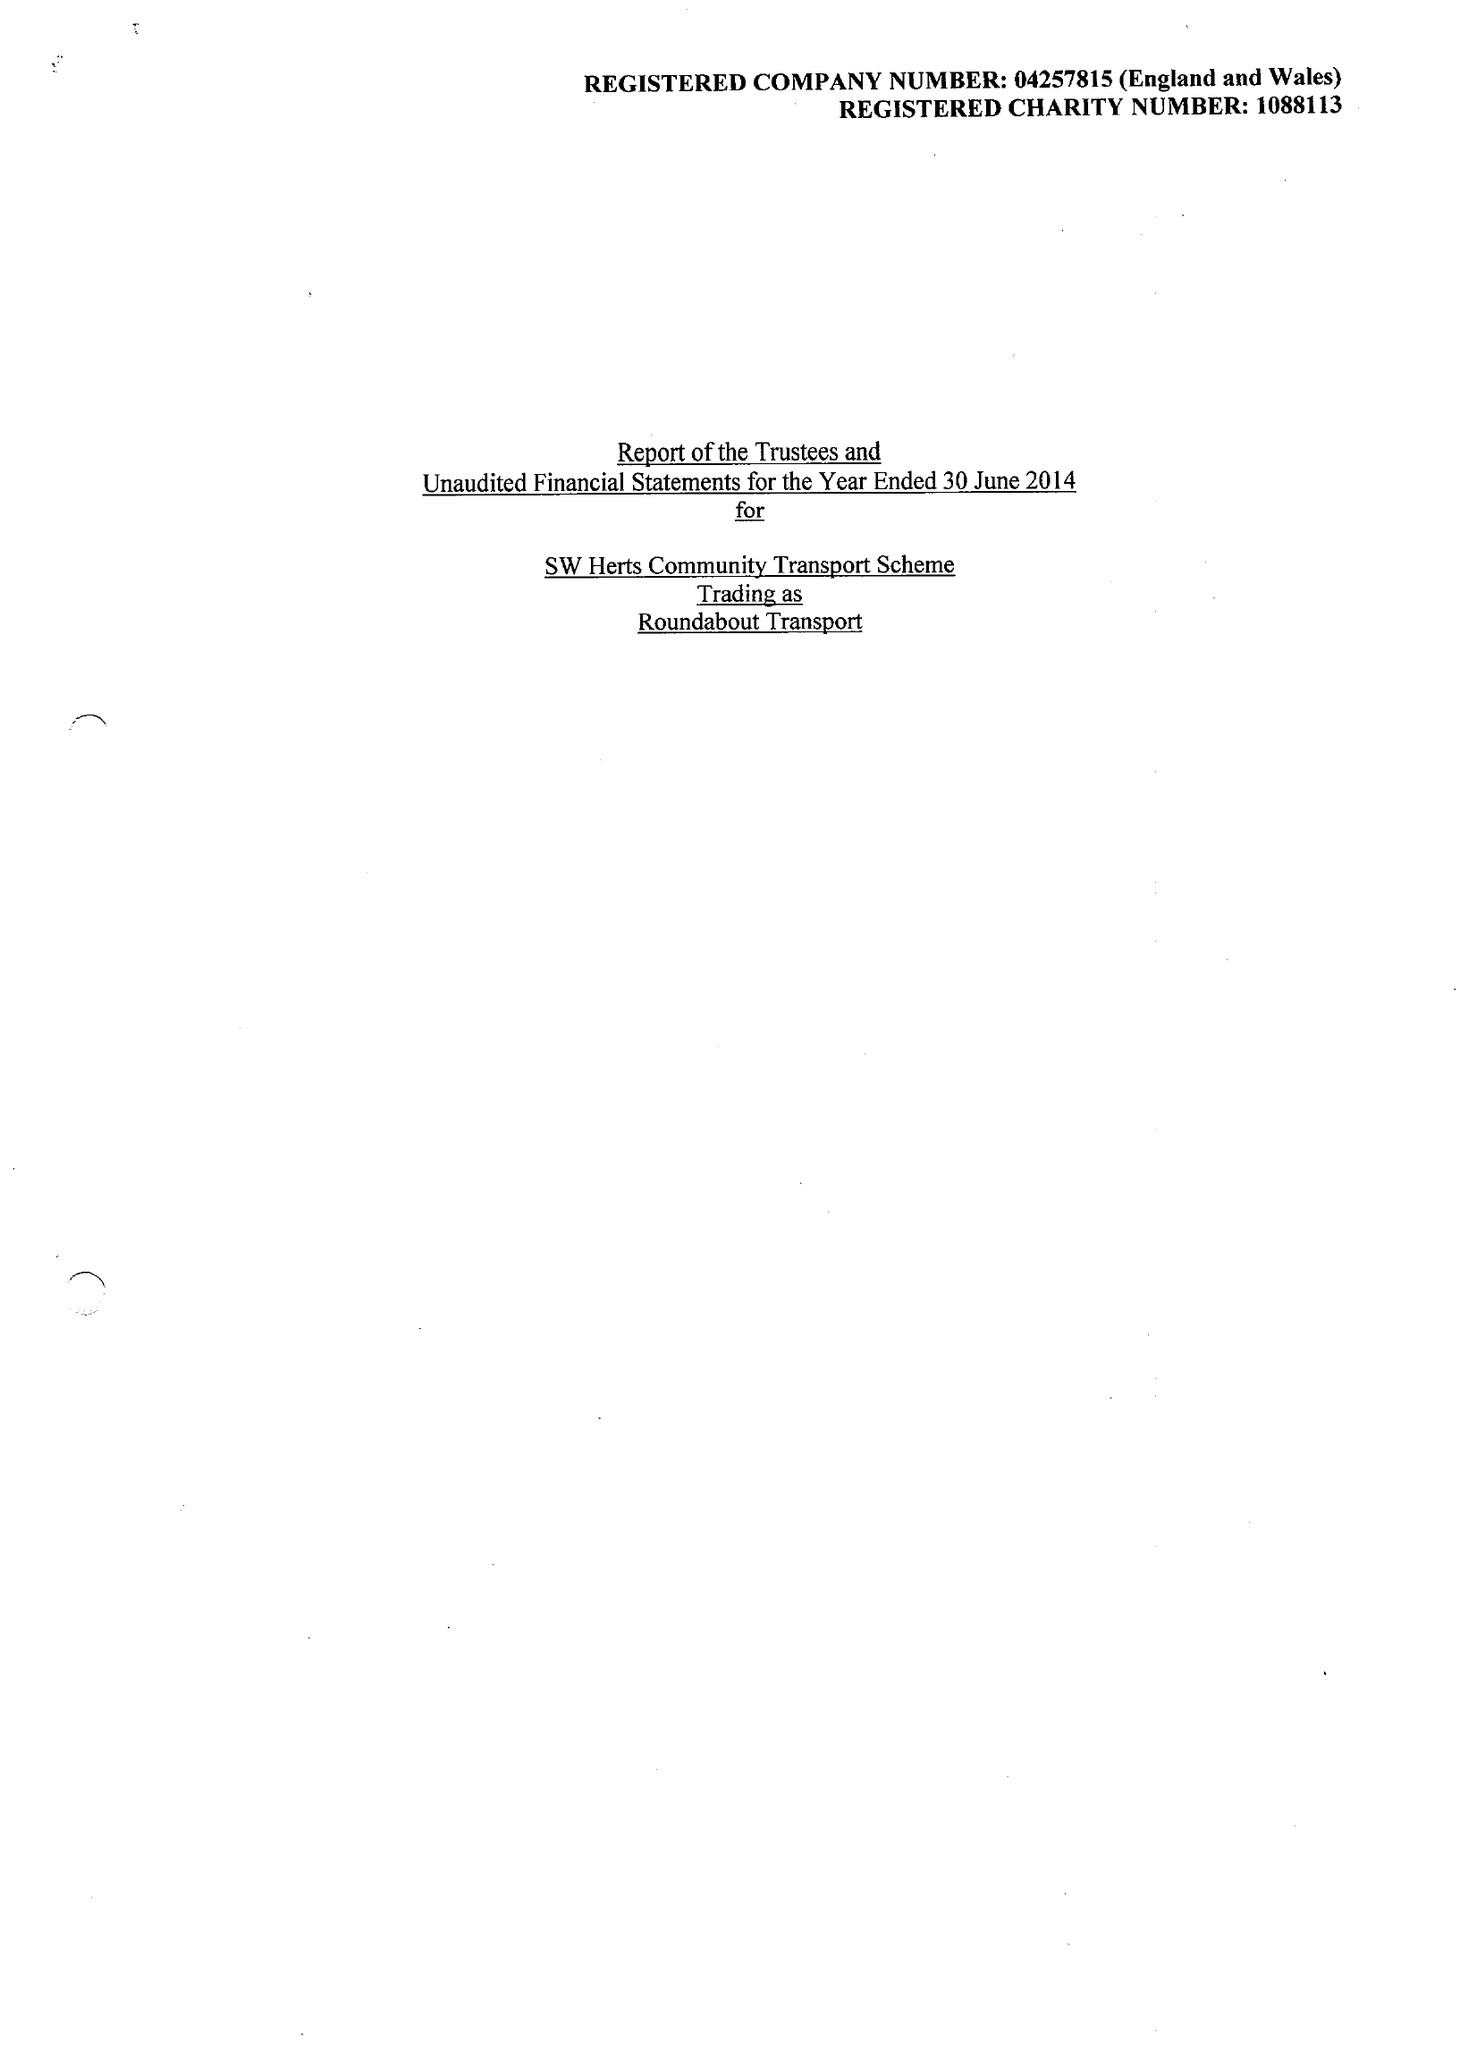What is the value for the address__postcode?
Answer the question using a single word or phrase. WD3 1DP 